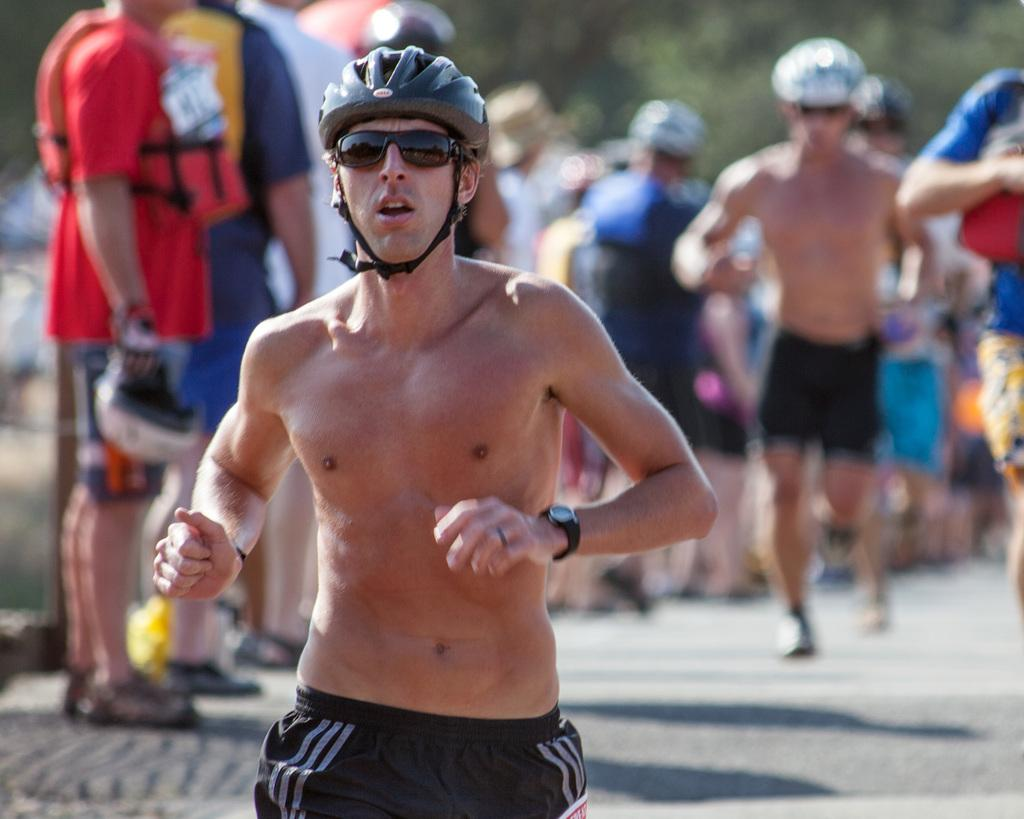What is present in the image? There are people in the image. What are the people wearing on their heads? The people are wearing helmets. What type of clothing are the people wearing on their lower bodies? The people are wearing shorts. What activity are the people engaged in? The people are running on the ground. What type of pet can be seen holding a whip in the image? There is no pet present in the image, and therefore no such activity can be observed. What type of skate is being used by the people in the image? There is no skate present in the image; the people are running on the ground. 